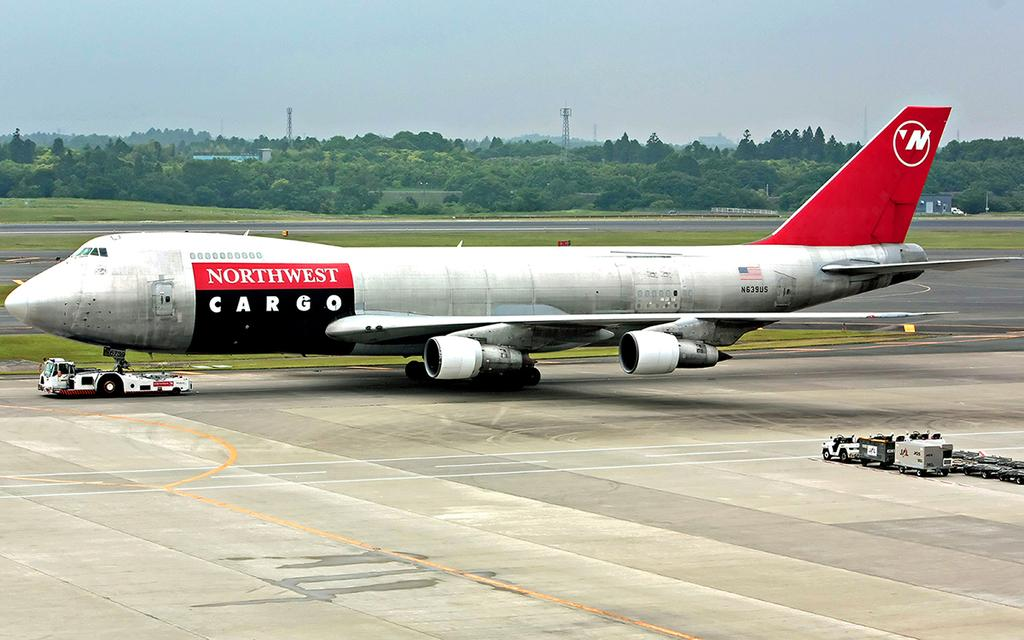Provide a one-sentence caption for the provided image. A Northwest Cargo plane is sitting on the runway. 